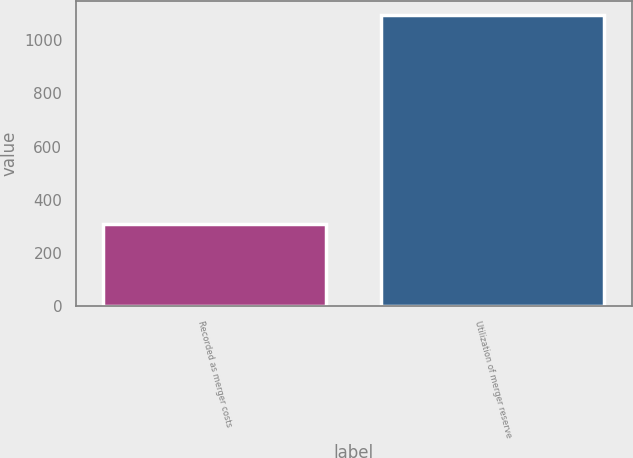Convert chart to OTSL. <chart><loc_0><loc_0><loc_500><loc_500><bar_chart><fcel>Recorded as merger costs<fcel>Utilization of merger reserve<nl><fcel>308<fcel>1093<nl></chart> 